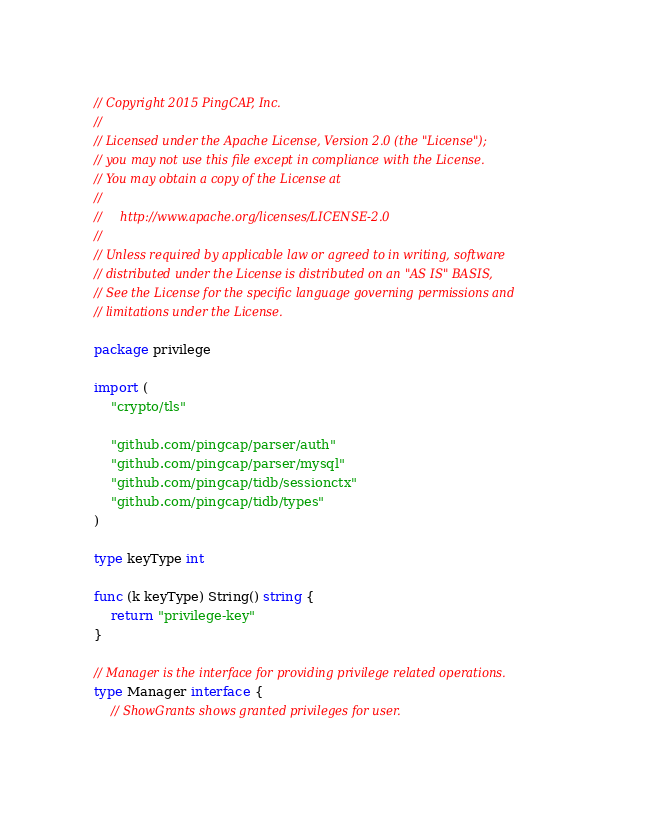<code> <loc_0><loc_0><loc_500><loc_500><_Go_>// Copyright 2015 PingCAP, Inc.
//
// Licensed under the Apache License, Version 2.0 (the "License");
// you may not use this file except in compliance with the License.
// You may obtain a copy of the License at
//
//     http://www.apache.org/licenses/LICENSE-2.0
//
// Unless required by applicable law or agreed to in writing, software
// distributed under the License is distributed on an "AS IS" BASIS,
// See the License for the specific language governing permissions and
// limitations under the License.

package privilege

import (
	"crypto/tls"

	"github.com/pingcap/parser/auth"
	"github.com/pingcap/parser/mysql"
	"github.com/pingcap/tidb/sessionctx"
	"github.com/pingcap/tidb/types"
)

type keyType int

func (k keyType) String() string {
	return "privilege-key"
}

// Manager is the interface for providing privilege related operations.
type Manager interface {
	// ShowGrants shows granted privileges for user.</code> 